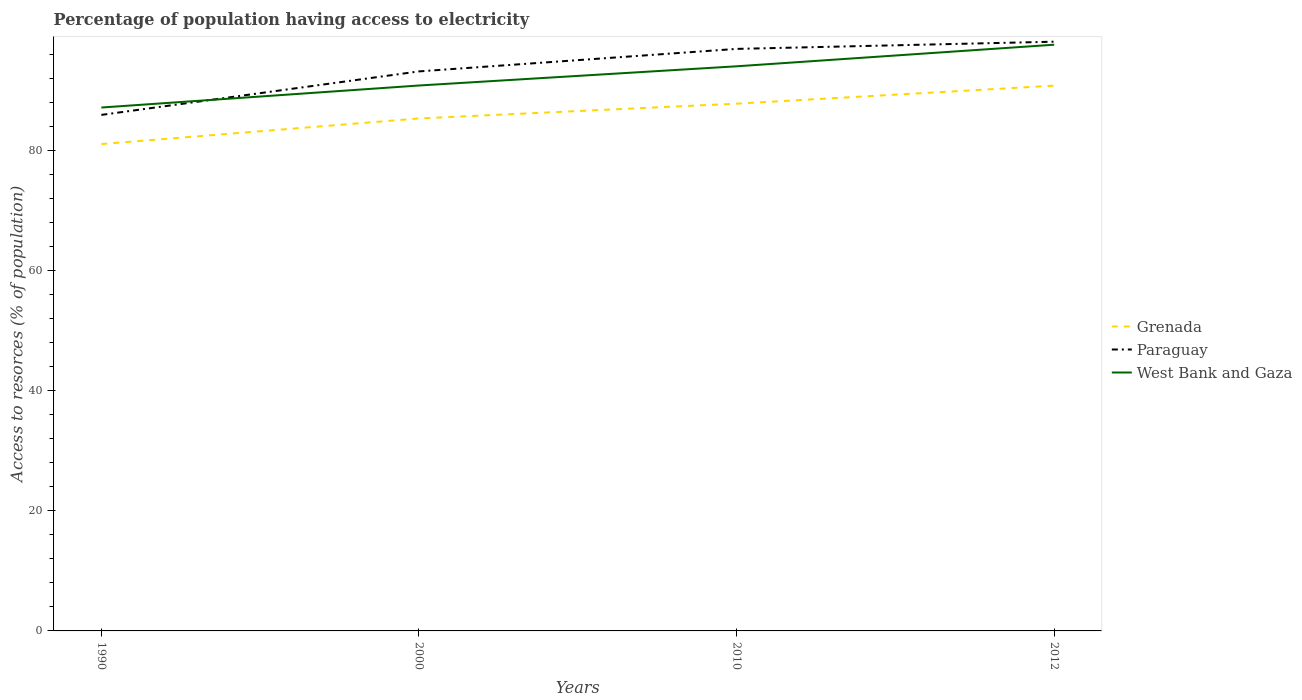How many different coloured lines are there?
Your answer should be very brief. 3. Does the line corresponding to West Bank and Gaza intersect with the line corresponding to Grenada?
Your answer should be compact. No. Across all years, what is the maximum percentage of population having access to electricity in Paraguay?
Provide a short and direct response. 86. In which year was the percentage of population having access to electricity in Grenada maximum?
Provide a short and direct response. 1990. What is the total percentage of population having access to electricity in Paraguay in the graph?
Offer a very short reply. -11. What is the difference between the highest and the second highest percentage of population having access to electricity in West Bank and Gaza?
Your response must be concise. 10.47. How many lines are there?
Your answer should be very brief. 3. What is the difference between two consecutive major ticks on the Y-axis?
Keep it short and to the point. 20. Where does the legend appear in the graph?
Keep it short and to the point. Center right. How many legend labels are there?
Provide a succinct answer. 3. What is the title of the graph?
Your response must be concise. Percentage of population having access to electricity. What is the label or title of the Y-axis?
Provide a succinct answer. Access to resorces (% of population). What is the Access to resorces (% of population) of Grenada in 1990?
Your response must be concise. 81.14. What is the Access to resorces (% of population) of Paraguay in 1990?
Provide a short and direct response. 86. What is the Access to resorces (% of population) in West Bank and Gaza in 1990?
Make the answer very short. 87.23. What is the Access to resorces (% of population) in Grenada in 2000?
Make the answer very short. 85.41. What is the Access to resorces (% of population) of Paraguay in 2000?
Provide a succinct answer. 93.25. What is the Access to resorces (% of population) in West Bank and Gaza in 2000?
Offer a very short reply. 90.9. What is the Access to resorces (% of population) of Grenada in 2010?
Keep it short and to the point. 87.87. What is the Access to resorces (% of population) in Paraguay in 2010?
Your response must be concise. 97. What is the Access to resorces (% of population) in West Bank and Gaza in 2010?
Offer a terse response. 94.1. What is the Access to resorces (% of population) in Grenada in 2012?
Offer a very short reply. 90.88. What is the Access to resorces (% of population) in Paraguay in 2012?
Offer a terse response. 98.2. What is the Access to resorces (% of population) of West Bank and Gaza in 2012?
Make the answer very short. 97.7. Across all years, what is the maximum Access to resorces (% of population) in Grenada?
Provide a short and direct response. 90.88. Across all years, what is the maximum Access to resorces (% of population) of Paraguay?
Make the answer very short. 98.2. Across all years, what is the maximum Access to resorces (% of population) of West Bank and Gaza?
Keep it short and to the point. 97.7. Across all years, what is the minimum Access to resorces (% of population) in Grenada?
Offer a very short reply. 81.14. Across all years, what is the minimum Access to resorces (% of population) of Paraguay?
Provide a short and direct response. 86. Across all years, what is the minimum Access to resorces (% of population) in West Bank and Gaza?
Provide a succinct answer. 87.23. What is the total Access to resorces (% of population) of Grenada in the graph?
Give a very brief answer. 345.3. What is the total Access to resorces (% of population) of Paraguay in the graph?
Offer a very short reply. 374.45. What is the total Access to resorces (% of population) of West Bank and Gaza in the graph?
Make the answer very short. 369.92. What is the difference between the Access to resorces (% of population) in Grenada in 1990 and that in 2000?
Offer a terse response. -4.28. What is the difference between the Access to resorces (% of population) in Paraguay in 1990 and that in 2000?
Provide a short and direct response. -7.25. What is the difference between the Access to resorces (% of population) in West Bank and Gaza in 1990 and that in 2000?
Your answer should be very brief. -3.67. What is the difference between the Access to resorces (% of population) of Grenada in 1990 and that in 2010?
Give a very brief answer. -6.74. What is the difference between the Access to resorces (% of population) of West Bank and Gaza in 1990 and that in 2010?
Give a very brief answer. -6.87. What is the difference between the Access to resorces (% of population) of Grenada in 1990 and that in 2012?
Your answer should be compact. -9.74. What is the difference between the Access to resorces (% of population) of Paraguay in 1990 and that in 2012?
Make the answer very short. -12.2. What is the difference between the Access to resorces (% of population) of West Bank and Gaza in 1990 and that in 2012?
Give a very brief answer. -10.47. What is the difference between the Access to resorces (% of population) of Grenada in 2000 and that in 2010?
Offer a terse response. -2.46. What is the difference between the Access to resorces (% of population) of Paraguay in 2000 and that in 2010?
Your answer should be compact. -3.75. What is the difference between the Access to resorces (% of population) of West Bank and Gaza in 2000 and that in 2010?
Offer a very short reply. -3.2. What is the difference between the Access to resorces (% of population) of Grenada in 2000 and that in 2012?
Your answer should be very brief. -5.46. What is the difference between the Access to resorces (% of population) of Paraguay in 2000 and that in 2012?
Your response must be concise. -4.95. What is the difference between the Access to resorces (% of population) in West Bank and Gaza in 2000 and that in 2012?
Give a very brief answer. -6.8. What is the difference between the Access to resorces (% of population) of Grenada in 2010 and that in 2012?
Keep it short and to the point. -3. What is the difference between the Access to resorces (% of population) of Paraguay in 2010 and that in 2012?
Ensure brevity in your answer.  -1.2. What is the difference between the Access to resorces (% of population) in West Bank and Gaza in 2010 and that in 2012?
Make the answer very short. -3.6. What is the difference between the Access to resorces (% of population) of Grenada in 1990 and the Access to resorces (% of population) of Paraguay in 2000?
Offer a terse response. -12.11. What is the difference between the Access to resorces (% of population) of Grenada in 1990 and the Access to resorces (% of population) of West Bank and Gaza in 2000?
Provide a short and direct response. -9.76. What is the difference between the Access to resorces (% of population) of Paraguay in 1990 and the Access to resorces (% of population) of West Bank and Gaza in 2000?
Ensure brevity in your answer.  -4.9. What is the difference between the Access to resorces (% of population) of Grenada in 1990 and the Access to resorces (% of population) of Paraguay in 2010?
Provide a short and direct response. -15.86. What is the difference between the Access to resorces (% of population) of Grenada in 1990 and the Access to resorces (% of population) of West Bank and Gaza in 2010?
Keep it short and to the point. -12.96. What is the difference between the Access to resorces (% of population) in Grenada in 1990 and the Access to resorces (% of population) in Paraguay in 2012?
Provide a succinct answer. -17.06. What is the difference between the Access to resorces (% of population) of Grenada in 1990 and the Access to resorces (% of population) of West Bank and Gaza in 2012?
Offer a very short reply. -16.56. What is the difference between the Access to resorces (% of population) in Paraguay in 1990 and the Access to resorces (% of population) in West Bank and Gaza in 2012?
Ensure brevity in your answer.  -11.7. What is the difference between the Access to resorces (% of population) in Grenada in 2000 and the Access to resorces (% of population) in Paraguay in 2010?
Provide a short and direct response. -11.59. What is the difference between the Access to resorces (% of population) in Grenada in 2000 and the Access to resorces (% of population) in West Bank and Gaza in 2010?
Your response must be concise. -8.69. What is the difference between the Access to resorces (% of population) in Paraguay in 2000 and the Access to resorces (% of population) in West Bank and Gaza in 2010?
Ensure brevity in your answer.  -0.85. What is the difference between the Access to resorces (% of population) in Grenada in 2000 and the Access to resorces (% of population) in Paraguay in 2012?
Provide a short and direct response. -12.79. What is the difference between the Access to resorces (% of population) of Grenada in 2000 and the Access to resorces (% of population) of West Bank and Gaza in 2012?
Your response must be concise. -12.29. What is the difference between the Access to resorces (% of population) of Paraguay in 2000 and the Access to resorces (% of population) of West Bank and Gaza in 2012?
Your response must be concise. -4.45. What is the difference between the Access to resorces (% of population) in Grenada in 2010 and the Access to resorces (% of population) in Paraguay in 2012?
Offer a very short reply. -10.33. What is the difference between the Access to resorces (% of population) in Grenada in 2010 and the Access to resorces (% of population) in West Bank and Gaza in 2012?
Ensure brevity in your answer.  -9.82. What is the difference between the Access to resorces (% of population) in Paraguay in 2010 and the Access to resorces (% of population) in West Bank and Gaza in 2012?
Provide a succinct answer. -0.7. What is the average Access to resorces (% of population) in Grenada per year?
Give a very brief answer. 86.32. What is the average Access to resorces (% of population) of Paraguay per year?
Your response must be concise. 93.61. What is the average Access to resorces (% of population) of West Bank and Gaza per year?
Ensure brevity in your answer.  92.48. In the year 1990, what is the difference between the Access to resorces (% of population) of Grenada and Access to resorces (% of population) of Paraguay?
Offer a very short reply. -4.86. In the year 1990, what is the difference between the Access to resorces (% of population) in Grenada and Access to resorces (% of population) in West Bank and Gaza?
Offer a terse response. -6.09. In the year 1990, what is the difference between the Access to resorces (% of population) in Paraguay and Access to resorces (% of population) in West Bank and Gaza?
Your answer should be compact. -1.23. In the year 2000, what is the difference between the Access to resorces (% of population) of Grenada and Access to resorces (% of population) of Paraguay?
Provide a succinct answer. -7.84. In the year 2000, what is the difference between the Access to resorces (% of population) in Grenada and Access to resorces (% of population) in West Bank and Gaza?
Give a very brief answer. -5.49. In the year 2000, what is the difference between the Access to resorces (% of population) in Paraguay and Access to resorces (% of population) in West Bank and Gaza?
Ensure brevity in your answer.  2.35. In the year 2010, what is the difference between the Access to resorces (% of population) of Grenada and Access to resorces (% of population) of Paraguay?
Your answer should be very brief. -9.13. In the year 2010, what is the difference between the Access to resorces (% of population) of Grenada and Access to resorces (% of population) of West Bank and Gaza?
Provide a short and direct response. -6.23. In the year 2012, what is the difference between the Access to resorces (% of population) in Grenada and Access to resorces (% of population) in Paraguay?
Your response must be concise. -7.32. In the year 2012, what is the difference between the Access to resorces (% of population) of Grenada and Access to resorces (% of population) of West Bank and Gaza?
Offer a very short reply. -6.82. In the year 2012, what is the difference between the Access to resorces (% of population) in Paraguay and Access to resorces (% of population) in West Bank and Gaza?
Provide a succinct answer. 0.5. What is the ratio of the Access to resorces (% of population) of Grenada in 1990 to that in 2000?
Your answer should be compact. 0.95. What is the ratio of the Access to resorces (% of population) of Paraguay in 1990 to that in 2000?
Provide a short and direct response. 0.92. What is the ratio of the Access to resorces (% of population) in West Bank and Gaza in 1990 to that in 2000?
Your response must be concise. 0.96. What is the ratio of the Access to resorces (% of population) of Grenada in 1990 to that in 2010?
Your answer should be compact. 0.92. What is the ratio of the Access to resorces (% of population) of Paraguay in 1990 to that in 2010?
Give a very brief answer. 0.89. What is the ratio of the Access to resorces (% of population) of West Bank and Gaza in 1990 to that in 2010?
Your answer should be very brief. 0.93. What is the ratio of the Access to resorces (% of population) of Grenada in 1990 to that in 2012?
Provide a succinct answer. 0.89. What is the ratio of the Access to resorces (% of population) of Paraguay in 1990 to that in 2012?
Your answer should be compact. 0.88. What is the ratio of the Access to resorces (% of population) in West Bank and Gaza in 1990 to that in 2012?
Ensure brevity in your answer.  0.89. What is the ratio of the Access to resorces (% of population) in Grenada in 2000 to that in 2010?
Offer a terse response. 0.97. What is the ratio of the Access to resorces (% of population) of Paraguay in 2000 to that in 2010?
Your answer should be very brief. 0.96. What is the ratio of the Access to resorces (% of population) of West Bank and Gaza in 2000 to that in 2010?
Your response must be concise. 0.97. What is the ratio of the Access to resorces (% of population) of Grenada in 2000 to that in 2012?
Your answer should be compact. 0.94. What is the ratio of the Access to resorces (% of population) in Paraguay in 2000 to that in 2012?
Provide a succinct answer. 0.95. What is the ratio of the Access to resorces (% of population) of West Bank and Gaza in 2000 to that in 2012?
Keep it short and to the point. 0.93. What is the ratio of the Access to resorces (% of population) in West Bank and Gaza in 2010 to that in 2012?
Give a very brief answer. 0.96. What is the difference between the highest and the second highest Access to resorces (% of population) of Grenada?
Offer a terse response. 3. What is the difference between the highest and the second highest Access to resorces (% of population) of Paraguay?
Your response must be concise. 1.2. What is the difference between the highest and the second highest Access to resorces (% of population) of West Bank and Gaza?
Offer a terse response. 3.6. What is the difference between the highest and the lowest Access to resorces (% of population) in Grenada?
Your answer should be very brief. 9.74. What is the difference between the highest and the lowest Access to resorces (% of population) in West Bank and Gaza?
Your answer should be compact. 10.47. 